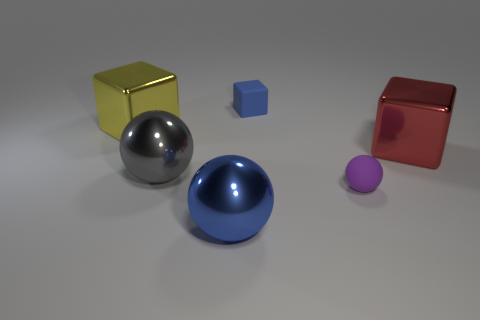Add 3 blue things. How many objects exist? 9 Add 5 large blue metal spheres. How many large blue metal spheres exist? 6 Subtract 1 red blocks. How many objects are left? 5 Subtract all big blue metal balls. Subtract all red metallic objects. How many objects are left? 4 Add 3 shiny objects. How many shiny objects are left? 7 